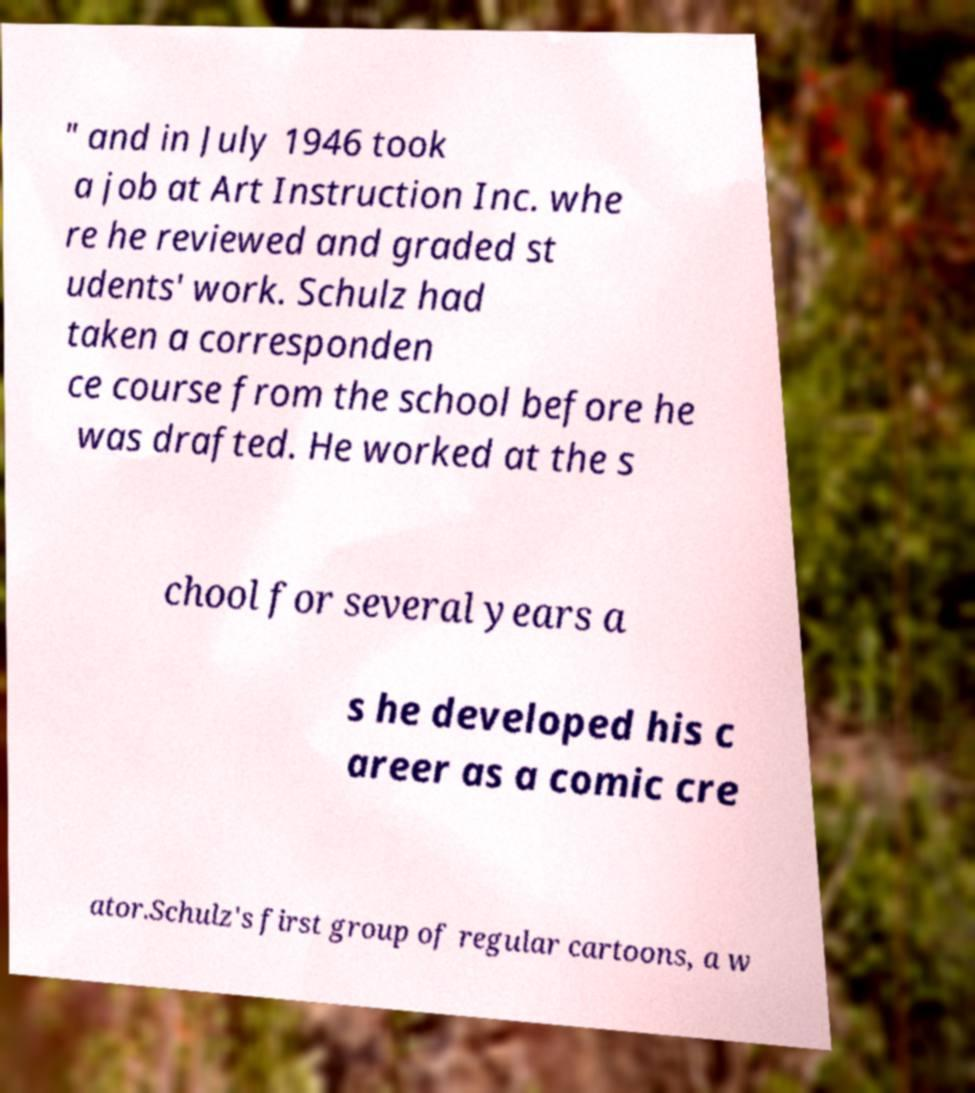Please read and relay the text visible in this image. What does it say? " and in July 1946 took a job at Art Instruction Inc. whe re he reviewed and graded st udents' work. Schulz had taken a corresponden ce course from the school before he was drafted. He worked at the s chool for several years a s he developed his c areer as a comic cre ator.Schulz's first group of regular cartoons, a w 